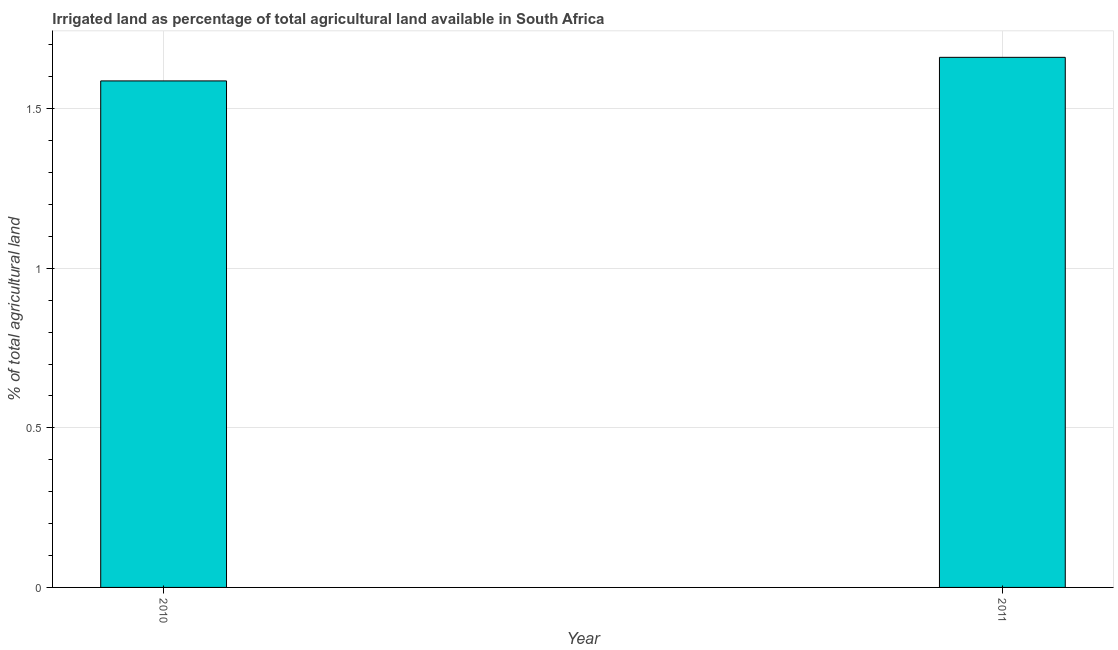Does the graph contain any zero values?
Your answer should be compact. No. Does the graph contain grids?
Ensure brevity in your answer.  Yes. What is the title of the graph?
Offer a very short reply. Irrigated land as percentage of total agricultural land available in South Africa. What is the label or title of the X-axis?
Give a very brief answer. Year. What is the label or title of the Y-axis?
Give a very brief answer. % of total agricultural land. What is the percentage of agricultural irrigated land in 2011?
Keep it short and to the point. 1.66. Across all years, what is the maximum percentage of agricultural irrigated land?
Ensure brevity in your answer.  1.66. Across all years, what is the minimum percentage of agricultural irrigated land?
Your answer should be compact. 1.59. In which year was the percentage of agricultural irrigated land maximum?
Give a very brief answer. 2011. In which year was the percentage of agricultural irrigated land minimum?
Ensure brevity in your answer.  2010. What is the sum of the percentage of agricultural irrigated land?
Give a very brief answer. 3.25. What is the difference between the percentage of agricultural irrigated land in 2010 and 2011?
Make the answer very short. -0.07. What is the average percentage of agricultural irrigated land per year?
Your answer should be compact. 1.62. What is the median percentage of agricultural irrigated land?
Keep it short and to the point. 1.62. What is the ratio of the percentage of agricultural irrigated land in 2010 to that in 2011?
Your answer should be compact. 0.96. Is the percentage of agricultural irrigated land in 2010 less than that in 2011?
Ensure brevity in your answer.  Yes. In how many years, is the percentage of agricultural irrigated land greater than the average percentage of agricultural irrigated land taken over all years?
Ensure brevity in your answer.  1. Are all the bars in the graph horizontal?
Offer a terse response. No. How many years are there in the graph?
Provide a succinct answer. 2. What is the % of total agricultural land in 2010?
Give a very brief answer. 1.59. What is the % of total agricultural land in 2011?
Your answer should be compact. 1.66. What is the difference between the % of total agricultural land in 2010 and 2011?
Your response must be concise. -0.07. What is the ratio of the % of total agricultural land in 2010 to that in 2011?
Provide a short and direct response. 0.96. 